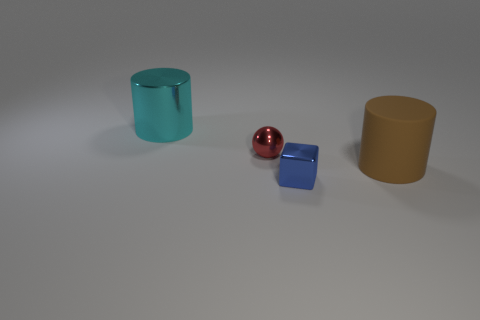Add 1 small metallic blocks. How many objects exist? 5 Subtract 0 cyan balls. How many objects are left? 4 Subtract all blocks. How many objects are left? 3 Subtract all gray cylinders. Subtract all brown cubes. How many cylinders are left? 2 Subtract all large brown cylinders. Subtract all small red metal objects. How many objects are left? 2 Add 1 spheres. How many spheres are left? 2 Add 2 large gray shiny balls. How many large gray shiny balls exist? 2 